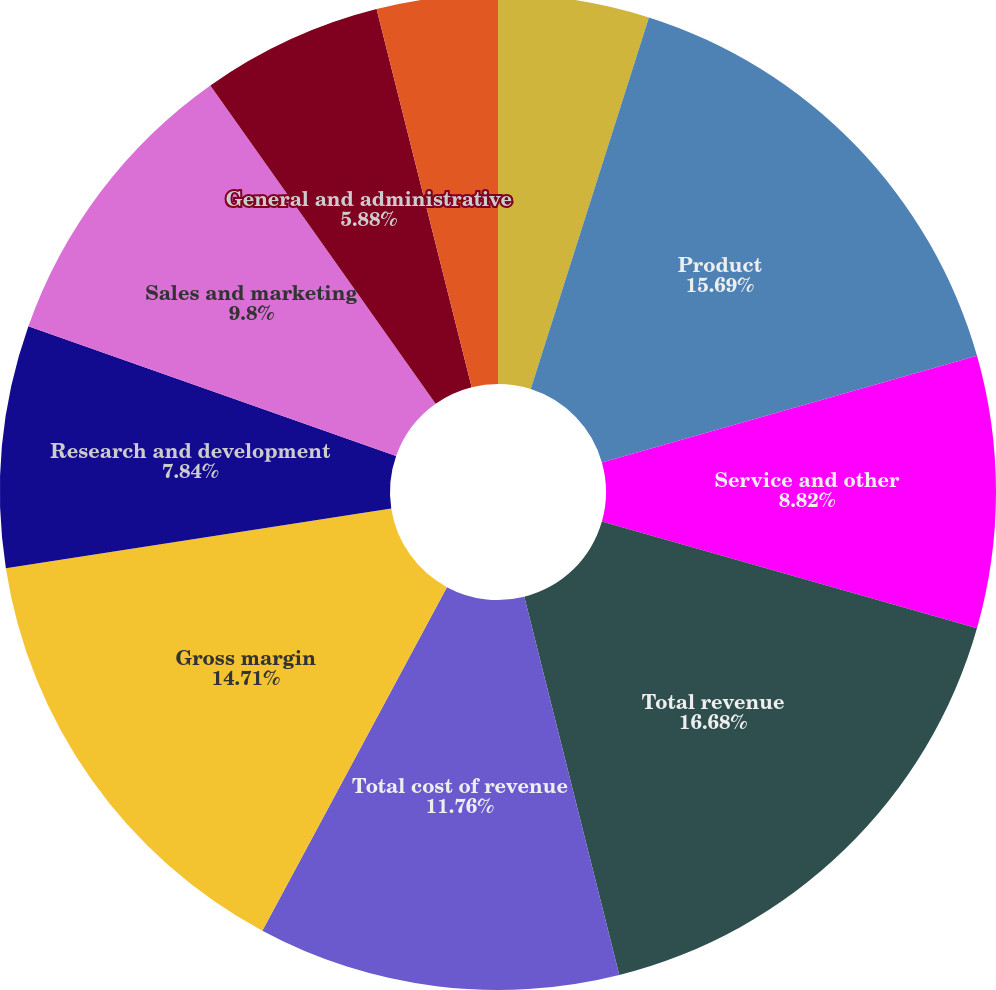<chart> <loc_0><loc_0><loc_500><loc_500><pie_chart><fcel>Year Ended June 30<fcel>Product<fcel>Service and other<fcel>Total revenue<fcel>Total cost of revenue<fcel>Gross margin<fcel>Research and development<fcel>Sales and marketing<fcel>General and administrative<fcel>Impairment integration and<nl><fcel>4.9%<fcel>15.69%<fcel>8.82%<fcel>16.67%<fcel>11.76%<fcel>14.71%<fcel>7.84%<fcel>9.8%<fcel>5.88%<fcel>3.92%<nl></chart> 